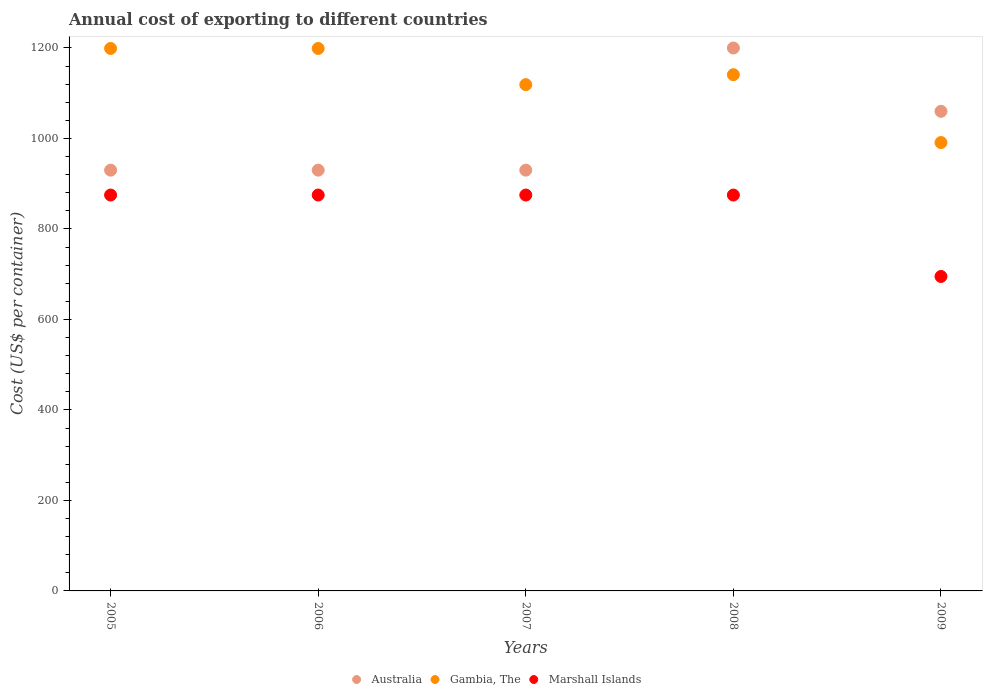Is the number of dotlines equal to the number of legend labels?
Ensure brevity in your answer.  Yes. What is the total annual cost of exporting in Marshall Islands in 2007?
Make the answer very short. 875. Across all years, what is the maximum total annual cost of exporting in Marshall Islands?
Keep it short and to the point. 875. Across all years, what is the minimum total annual cost of exporting in Australia?
Provide a succinct answer. 930. In which year was the total annual cost of exporting in Marshall Islands minimum?
Ensure brevity in your answer.  2009. What is the total total annual cost of exporting in Gambia, The in the graph?
Your response must be concise. 5649. What is the difference between the total annual cost of exporting in Gambia, The in 2005 and that in 2007?
Provide a succinct answer. 80. What is the difference between the total annual cost of exporting in Gambia, The in 2006 and the total annual cost of exporting in Marshall Islands in 2009?
Your answer should be compact. 504. What is the average total annual cost of exporting in Gambia, The per year?
Make the answer very short. 1129.8. In the year 2009, what is the difference between the total annual cost of exporting in Marshall Islands and total annual cost of exporting in Australia?
Make the answer very short. -365. What is the ratio of the total annual cost of exporting in Australia in 2006 to that in 2009?
Your answer should be very brief. 0.88. Is the total annual cost of exporting in Gambia, The in 2007 less than that in 2009?
Offer a terse response. No. Is the difference between the total annual cost of exporting in Marshall Islands in 2007 and 2009 greater than the difference between the total annual cost of exporting in Australia in 2007 and 2009?
Your answer should be very brief. Yes. What is the difference between the highest and the lowest total annual cost of exporting in Australia?
Give a very brief answer. 270. Does the total annual cost of exporting in Marshall Islands monotonically increase over the years?
Keep it short and to the point. No. Is the total annual cost of exporting in Australia strictly greater than the total annual cost of exporting in Marshall Islands over the years?
Your answer should be compact. Yes. Is the total annual cost of exporting in Marshall Islands strictly less than the total annual cost of exporting in Australia over the years?
Keep it short and to the point. Yes. How many dotlines are there?
Give a very brief answer. 3. How many years are there in the graph?
Offer a very short reply. 5. What is the difference between two consecutive major ticks on the Y-axis?
Offer a terse response. 200. Does the graph contain any zero values?
Give a very brief answer. No. Does the graph contain grids?
Provide a short and direct response. No. Where does the legend appear in the graph?
Make the answer very short. Bottom center. How many legend labels are there?
Your answer should be compact. 3. What is the title of the graph?
Offer a very short reply. Annual cost of exporting to different countries. Does "France" appear as one of the legend labels in the graph?
Offer a terse response. No. What is the label or title of the X-axis?
Provide a short and direct response. Years. What is the label or title of the Y-axis?
Keep it short and to the point. Cost (US$ per container). What is the Cost (US$ per container) of Australia in 2005?
Offer a terse response. 930. What is the Cost (US$ per container) of Gambia, The in 2005?
Offer a terse response. 1199. What is the Cost (US$ per container) in Marshall Islands in 2005?
Keep it short and to the point. 875. What is the Cost (US$ per container) in Australia in 2006?
Your response must be concise. 930. What is the Cost (US$ per container) of Gambia, The in 2006?
Offer a very short reply. 1199. What is the Cost (US$ per container) of Marshall Islands in 2006?
Give a very brief answer. 875. What is the Cost (US$ per container) in Australia in 2007?
Offer a very short reply. 930. What is the Cost (US$ per container) in Gambia, The in 2007?
Keep it short and to the point. 1119. What is the Cost (US$ per container) in Marshall Islands in 2007?
Provide a short and direct response. 875. What is the Cost (US$ per container) in Australia in 2008?
Make the answer very short. 1200. What is the Cost (US$ per container) of Gambia, The in 2008?
Offer a terse response. 1141. What is the Cost (US$ per container) of Marshall Islands in 2008?
Ensure brevity in your answer.  875. What is the Cost (US$ per container) in Australia in 2009?
Make the answer very short. 1060. What is the Cost (US$ per container) of Gambia, The in 2009?
Provide a succinct answer. 991. What is the Cost (US$ per container) of Marshall Islands in 2009?
Offer a terse response. 695. Across all years, what is the maximum Cost (US$ per container) in Australia?
Offer a very short reply. 1200. Across all years, what is the maximum Cost (US$ per container) of Gambia, The?
Offer a terse response. 1199. Across all years, what is the maximum Cost (US$ per container) in Marshall Islands?
Give a very brief answer. 875. Across all years, what is the minimum Cost (US$ per container) of Australia?
Your answer should be very brief. 930. Across all years, what is the minimum Cost (US$ per container) of Gambia, The?
Provide a succinct answer. 991. Across all years, what is the minimum Cost (US$ per container) of Marshall Islands?
Provide a short and direct response. 695. What is the total Cost (US$ per container) in Australia in the graph?
Give a very brief answer. 5050. What is the total Cost (US$ per container) in Gambia, The in the graph?
Give a very brief answer. 5649. What is the total Cost (US$ per container) of Marshall Islands in the graph?
Offer a terse response. 4195. What is the difference between the Cost (US$ per container) of Australia in 2005 and that in 2006?
Your response must be concise. 0. What is the difference between the Cost (US$ per container) in Gambia, The in 2005 and that in 2006?
Your answer should be compact. 0. What is the difference between the Cost (US$ per container) in Australia in 2005 and that in 2007?
Your answer should be very brief. 0. What is the difference between the Cost (US$ per container) of Gambia, The in 2005 and that in 2007?
Make the answer very short. 80. What is the difference between the Cost (US$ per container) of Australia in 2005 and that in 2008?
Keep it short and to the point. -270. What is the difference between the Cost (US$ per container) of Australia in 2005 and that in 2009?
Offer a very short reply. -130. What is the difference between the Cost (US$ per container) in Gambia, The in 2005 and that in 2009?
Keep it short and to the point. 208. What is the difference between the Cost (US$ per container) of Marshall Islands in 2005 and that in 2009?
Offer a terse response. 180. What is the difference between the Cost (US$ per container) in Australia in 2006 and that in 2007?
Offer a very short reply. 0. What is the difference between the Cost (US$ per container) of Australia in 2006 and that in 2008?
Provide a succinct answer. -270. What is the difference between the Cost (US$ per container) of Australia in 2006 and that in 2009?
Make the answer very short. -130. What is the difference between the Cost (US$ per container) in Gambia, The in 2006 and that in 2009?
Provide a succinct answer. 208. What is the difference between the Cost (US$ per container) in Marshall Islands in 2006 and that in 2009?
Offer a very short reply. 180. What is the difference between the Cost (US$ per container) in Australia in 2007 and that in 2008?
Provide a short and direct response. -270. What is the difference between the Cost (US$ per container) of Marshall Islands in 2007 and that in 2008?
Your response must be concise. 0. What is the difference between the Cost (US$ per container) in Australia in 2007 and that in 2009?
Offer a very short reply. -130. What is the difference between the Cost (US$ per container) in Gambia, The in 2007 and that in 2009?
Your answer should be very brief. 128. What is the difference between the Cost (US$ per container) in Marshall Islands in 2007 and that in 2009?
Your answer should be compact. 180. What is the difference between the Cost (US$ per container) in Australia in 2008 and that in 2009?
Give a very brief answer. 140. What is the difference between the Cost (US$ per container) in Gambia, The in 2008 and that in 2009?
Keep it short and to the point. 150. What is the difference between the Cost (US$ per container) in Marshall Islands in 2008 and that in 2009?
Ensure brevity in your answer.  180. What is the difference between the Cost (US$ per container) of Australia in 2005 and the Cost (US$ per container) of Gambia, The in 2006?
Ensure brevity in your answer.  -269. What is the difference between the Cost (US$ per container) in Gambia, The in 2005 and the Cost (US$ per container) in Marshall Islands in 2006?
Offer a very short reply. 324. What is the difference between the Cost (US$ per container) of Australia in 2005 and the Cost (US$ per container) of Gambia, The in 2007?
Your response must be concise. -189. What is the difference between the Cost (US$ per container) of Gambia, The in 2005 and the Cost (US$ per container) of Marshall Islands in 2007?
Offer a very short reply. 324. What is the difference between the Cost (US$ per container) in Australia in 2005 and the Cost (US$ per container) in Gambia, The in 2008?
Your answer should be compact. -211. What is the difference between the Cost (US$ per container) in Australia in 2005 and the Cost (US$ per container) in Marshall Islands in 2008?
Your answer should be compact. 55. What is the difference between the Cost (US$ per container) of Gambia, The in 2005 and the Cost (US$ per container) of Marshall Islands in 2008?
Your answer should be compact. 324. What is the difference between the Cost (US$ per container) in Australia in 2005 and the Cost (US$ per container) in Gambia, The in 2009?
Ensure brevity in your answer.  -61. What is the difference between the Cost (US$ per container) in Australia in 2005 and the Cost (US$ per container) in Marshall Islands in 2009?
Offer a very short reply. 235. What is the difference between the Cost (US$ per container) of Gambia, The in 2005 and the Cost (US$ per container) of Marshall Islands in 2009?
Your response must be concise. 504. What is the difference between the Cost (US$ per container) of Australia in 2006 and the Cost (US$ per container) of Gambia, The in 2007?
Your response must be concise. -189. What is the difference between the Cost (US$ per container) in Australia in 2006 and the Cost (US$ per container) in Marshall Islands in 2007?
Offer a terse response. 55. What is the difference between the Cost (US$ per container) of Gambia, The in 2006 and the Cost (US$ per container) of Marshall Islands in 2007?
Make the answer very short. 324. What is the difference between the Cost (US$ per container) of Australia in 2006 and the Cost (US$ per container) of Gambia, The in 2008?
Give a very brief answer. -211. What is the difference between the Cost (US$ per container) in Australia in 2006 and the Cost (US$ per container) in Marshall Islands in 2008?
Keep it short and to the point. 55. What is the difference between the Cost (US$ per container) of Gambia, The in 2006 and the Cost (US$ per container) of Marshall Islands in 2008?
Offer a very short reply. 324. What is the difference between the Cost (US$ per container) of Australia in 2006 and the Cost (US$ per container) of Gambia, The in 2009?
Provide a succinct answer. -61. What is the difference between the Cost (US$ per container) in Australia in 2006 and the Cost (US$ per container) in Marshall Islands in 2009?
Provide a short and direct response. 235. What is the difference between the Cost (US$ per container) in Gambia, The in 2006 and the Cost (US$ per container) in Marshall Islands in 2009?
Offer a very short reply. 504. What is the difference between the Cost (US$ per container) of Australia in 2007 and the Cost (US$ per container) of Gambia, The in 2008?
Give a very brief answer. -211. What is the difference between the Cost (US$ per container) of Gambia, The in 2007 and the Cost (US$ per container) of Marshall Islands in 2008?
Keep it short and to the point. 244. What is the difference between the Cost (US$ per container) of Australia in 2007 and the Cost (US$ per container) of Gambia, The in 2009?
Keep it short and to the point. -61. What is the difference between the Cost (US$ per container) in Australia in 2007 and the Cost (US$ per container) in Marshall Islands in 2009?
Make the answer very short. 235. What is the difference between the Cost (US$ per container) of Gambia, The in 2007 and the Cost (US$ per container) of Marshall Islands in 2009?
Ensure brevity in your answer.  424. What is the difference between the Cost (US$ per container) in Australia in 2008 and the Cost (US$ per container) in Gambia, The in 2009?
Ensure brevity in your answer.  209. What is the difference between the Cost (US$ per container) of Australia in 2008 and the Cost (US$ per container) of Marshall Islands in 2009?
Provide a succinct answer. 505. What is the difference between the Cost (US$ per container) in Gambia, The in 2008 and the Cost (US$ per container) in Marshall Islands in 2009?
Your answer should be very brief. 446. What is the average Cost (US$ per container) in Australia per year?
Give a very brief answer. 1010. What is the average Cost (US$ per container) in Gambia, The per year?
Offer a terse response. 1129.8. What is the average Cost (US$ per container) in Marshall Islands per year?
Give a very brief answer. 839. In the year 2005, what is the difference between the Cost (US$ per container) of Australia and Cost (US$ per container) of Gambia, The?
Your response must be concise. -269. In the year 2005, what is the difference between the Cost (US$ per container) in Gambia, The and Cost (US$ per container) in Marshall Islands?
Your response must be concise. 324. In the year 2006, what is the difference between the Cost (US$ per container) in Australia and Cost (US$ per container) in Gambia, The?
Offer a terse response. -269. In the year 2006, what is the difference between the Cost (US$ per container) of Gambia, The and Cost (US$ per container) of Marshall Islands?
Provide a short and direct response. 324. In the year 2007, what is the difference between the Cost (US$ per container) of Australia and Cost (US$ per container) of Gambia, The?
Offer a terse response. -189. In the year 2007, what is the difference between the Cost (US$ per container) in Australia and Cost (US$ per container) in Marshall Islands?
Provide a succinct answer. 55. In the year 2007, what is the difference between the Cost (US$ per container) of Gambia, The and Cost (US$ per container) of Marshall Islands?
Provide a succinct answer. 244. In the year 2008, what is the difference between the Cost (US$ per container) in Australia and Cost (US$ per container) in Marshall Islands?
Keep it short and to the point. 325. In the year 2008, what is the difference between the Cost (US$ per container) of Gambia, The and Cost (US$ per container) of Marshall Islands?
Your answer should be very brief. 266. In the year 2009, what is the difference between the Cost (US$ per container) of Australia and Cost (US$ per container) of Marshall Islands?
Your response must be concise. 365. In the year 2009, what is the difference between the Cost (US$ per container) in Gambia, The and Cost (US$ per container) in Marshall Islands?
Ensure brevity in your answer.  296. What is the ratio of the Cost (US$ per container) in Gambia, The in 2005 to that in 2006?
Provide a short and direct response. 1. What is the ratio of the Cost (US$ per container) in Marshall Islands in 2005 to that in 2006?
Your response must be concise. 1. What is the ratio of the Cost (US$ per container) of Gambia, The in 2005 to that in 2007?
Your answer should be compact. 1.07. What is the ratio of the Cost (US$ per container) in Marshall Islands in 2005 to that in 2007?
Offer a terse response. 1. What is the ratio of the Cost (US$ per container) in Australia in 2005 to that in 2008?
Your answer should be compact. 0.78. What is the ratio of the Cost (US$ per container) of Gambia, The in 2005 to that in 2008?
Provide a succinct answer. 1.05. What is the ratio of the Cost (US$ per container) in Australia in 2005 to that in 2009?
Provide a short and direct response. 0.88. What is the ratio of the Cost (US$ per container) in Gambia, The in 2005 to that in 2009?
Offer a terse response. 1.21. What is the ratio of the Cost (US$ per container) in Marshall Islands in 2005 to that in 2009?
Provide a succinct answer. 1.26. What is the ratio of the Cost (US$ per container) of Gambia, The in 2006 to that in 2007?
Your response must be concise. 1.07. What is the ratio of the Cost (US$ per container) in Marshall Islands in 2006 to that in 2007?
Make the answer very short. 1. What is the ratio of the Cost (US$ per container) of Australia in 2006 to that in 2008?
Your response must be concise. 0.78. What is the ratio of the Cost (US$ per container) of Gambia, The in 2006 to that in 2008?
Your answer should be very brief. 1.05. What is the ratio of the Cost (US$ per container) of Australia in 2006 to that in 2009?
Keep it short and to the point. 0.88. What is the ratio of the Cost (US$ per container) in Gambia, The in 2006 to that in 2009?
Ensure brevity in your answer.  1.21. What is the ratio of the Cost (US$ per container) in Marshall Islands in 2006 to that in 2009?
Keep it short and to the point. 1.26. What is the ratio of the Cost (US$ per container) in Australia in 2007 to that in 2008?
Give a very brief answer. 0.78. What is the ratio of the Cost (US$ per container) in Gambia, The in 2007 to that in 2008?
Offer a very short reply. 0.98. What is the ratio of the Cost (US$ per container) of Australia in 2007 to that in 2009?
Provide a succinct answer. 0.88. What is the ratio of the Cost (US$ per container) in Gambia, The in 2007 to that in 2009?
Your response must be concise. 1.13. What is the ratio of the Cost (US$ per container) of Marshall Islands in 2007 to that in 2009?
Keep it short and to the point. 1.26. What is the ratio of the Cost (US$ per container) of Australia in 2008 to that in 2009?
Your answer should be very brief. 1.13. What is the ratio of the Cost (US$ per container) of Gambia, The in 2008 to that in 2009?
Offer a terse response. 1.15. What is the ratio of the Cost (US$ per container) of Marshall Islands in 2008 to that in 2009?
Provide a succinct answer. 1.26. What is the difference between the highest and the second highest Cost (US$ per container) in Australia?
Your answer should be compact. 140. What is the difference between the highest and the second highest Cost (US$ per container) of Marshall Islands?
Keep it short and to the point. 0. What is the difference between the highest and the lowest Cost (US$ per container) of Australia?
Offer a very short reply. 270. What is the difference between the highest and the lowest Cost (US$ per container) in Gambia, The?
Your answer should be compact. 208. What is the difference between the highest and the lowest Cost (US$ per container) of Marshall Islands?
Your answer should be compact. 180. 